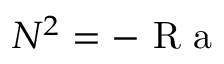Convert formula to latex. <formula><loc_0><loc_0><loc_500><loc_500>N ^ { 2 } = - R a</formula> 